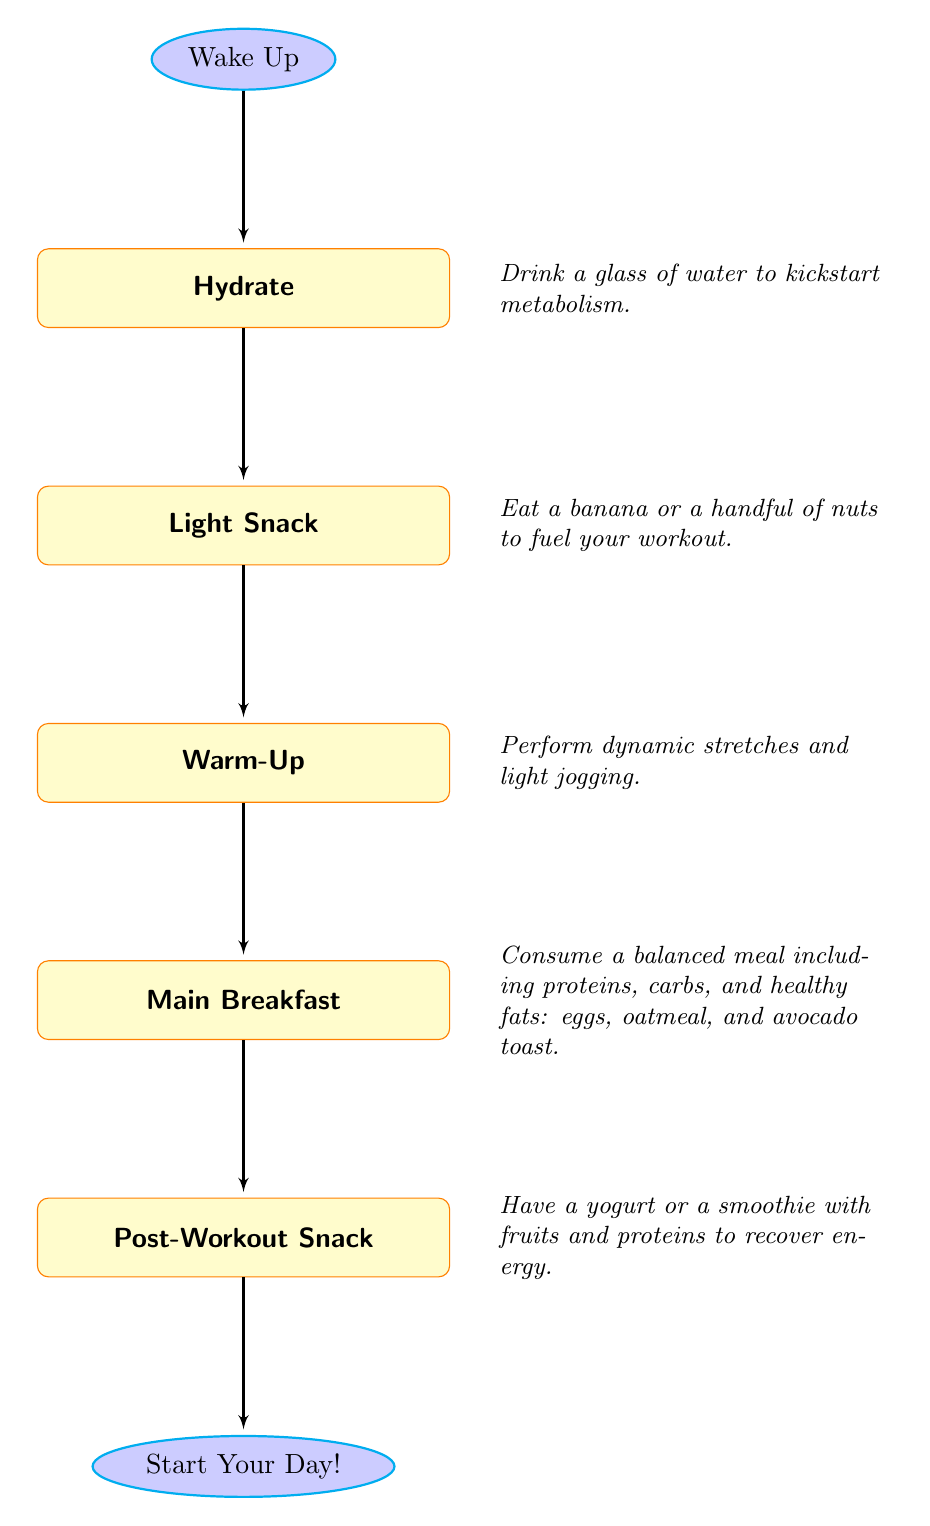What is the first step in the morning nutrition plan? The flow chart starts with the node labeled "Wake Up", indicating it is the initial step before any other activity.
Answer: Wake Up How many steps are included in the morning nutrition plan? There are five nodes representing key steps after waking up, leading to the end, thus the total count includes six steps: start, hydrate, snack, warm-up, breakfast, and post-workout snack.
Answer: Five What follows after hydrating? The flow indicates that after the "Hydrate" step, the next node is "Light Snack", which is where you consume a small food item.
Answer: Light Snack What should you consume for the main breakfast? The "Main Breakfast" node lists several items to eat, specifically mentioning eggs, oatmeal, and avocado toast as part of a balanced meal.
Answer: Eggs, oatmeal, avocado toast What do you have after the main breakfast? Following the "Main Breakfast", the next step is "Post-Workout Snack", suggesting that this is what should be consumed next.
Answer: Post-Workout Snack What is the purpose of the light snack? The description for the "Light Snack" node notes its purpose as fueling your workout by suggesting options like a banana or nuts.
Answer: Fuel your workout How are the activities structured in the flow chart? The activities are structured in a sequential manner, where each node leads directly to the next one, denoting a progression from waking up through hydration and snacks to the final recovery after the workout.
Answer: Sequential What is the last step mentioned in the nutrition plan? The last node in the flow chart is labeled "Start Your Day!", marking the conclusion of the morning nutrition plan activities.
Answer: Start Your Day! 